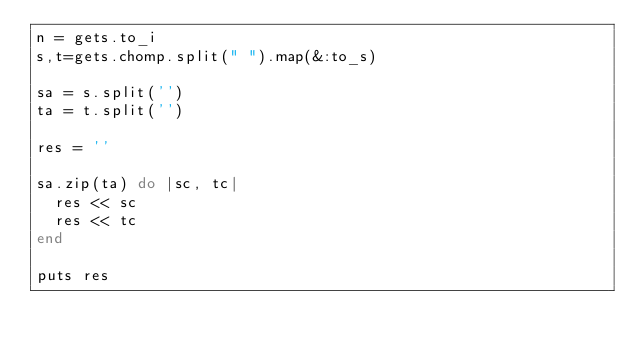<code> <loc_0><loc_0><loc_500><loc_500><_Ruby_>n = gets.to_i
s,t=gets.chomp.split(" ").map(&:to_s)

sa = s.split('')
ta = t.split('')

res = ''

sa.zip(ta) do |sc, tc|
  res << sc
  res << tc
end

puts res</code> 